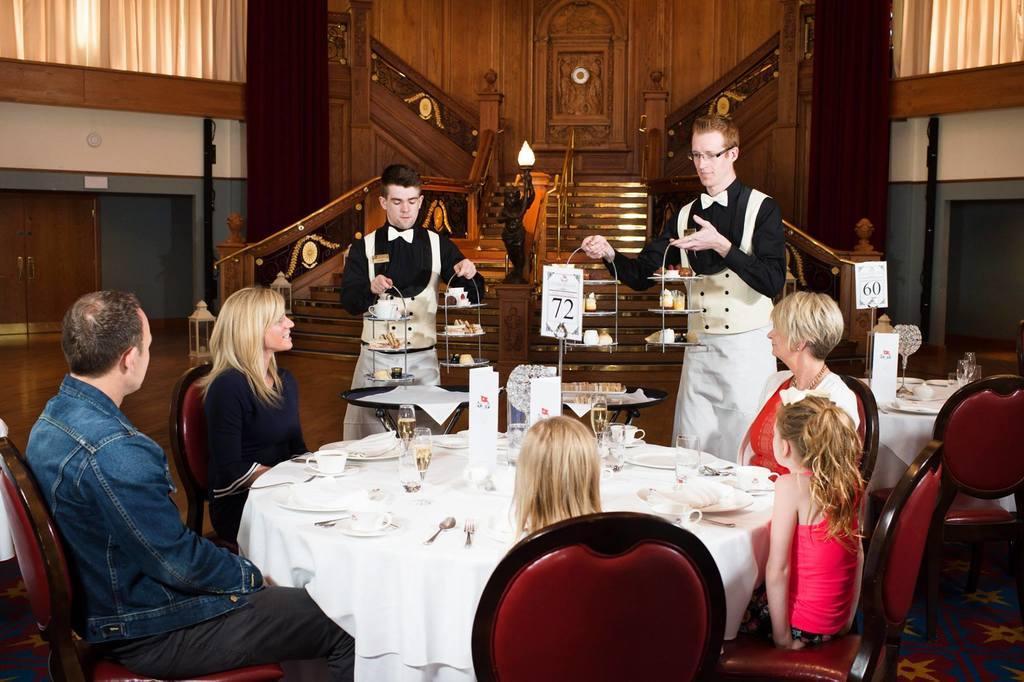Could you give a brief overview of what you see in this image? In the image we can see some peoples were sitting and some people were standing around the table. And coming to the background we can see the building. 